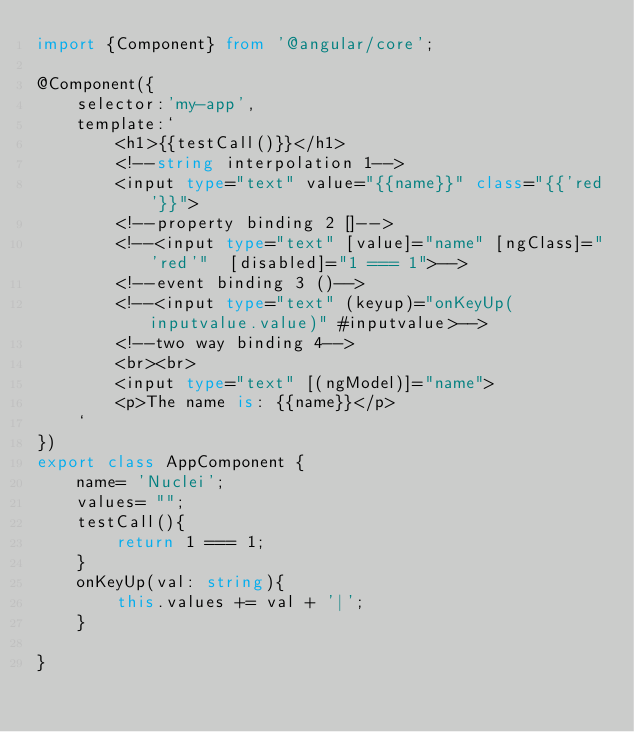<code> <loc_0><loc_0><loc_500><loc_500><_TypeScript_>import {Component} from '@angular/core';

@Component({
    selector:'my-app',
    template:`
        <h1>{{testCall()}}</h1>
        <!--string interpolation 1-->
        <input type="text" value="{{name}}" class="{{'red'}}">
        <!--property binding 2 []-->
        <!--<input type="text" [value]="name" [ngClass]="'red'"  [disabled]="1 === 1">-->
        <!--event binding 3 ()-->
        <!--<input type="text" (keyup)="onKeyUp(inputvalue.value)" #inputvalue>-->
        <!--two way binding 4-->
        <br><br>
        <input type="text" [(ngModel)]="name">
        <p>The name is: {{name}}</p>
    `
})
export class AppComponent {
    name= 'Nuclei';
    values= "";
    testCall(){
        return 1 === 1;
    }
    onKeyUp(val: string){
        this.values += val + '|';
    }

}</code> 